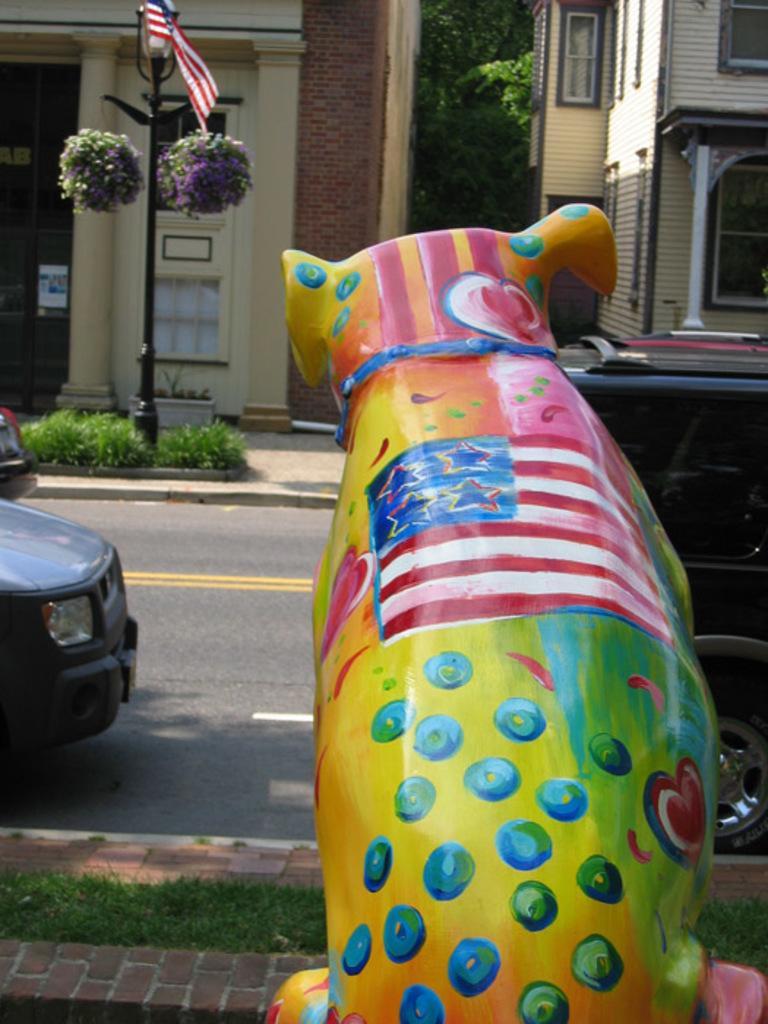Could you give a brief overview of what you see in this image? This image consists of buildings at the top, cars in the middle. There are trees at the top. 